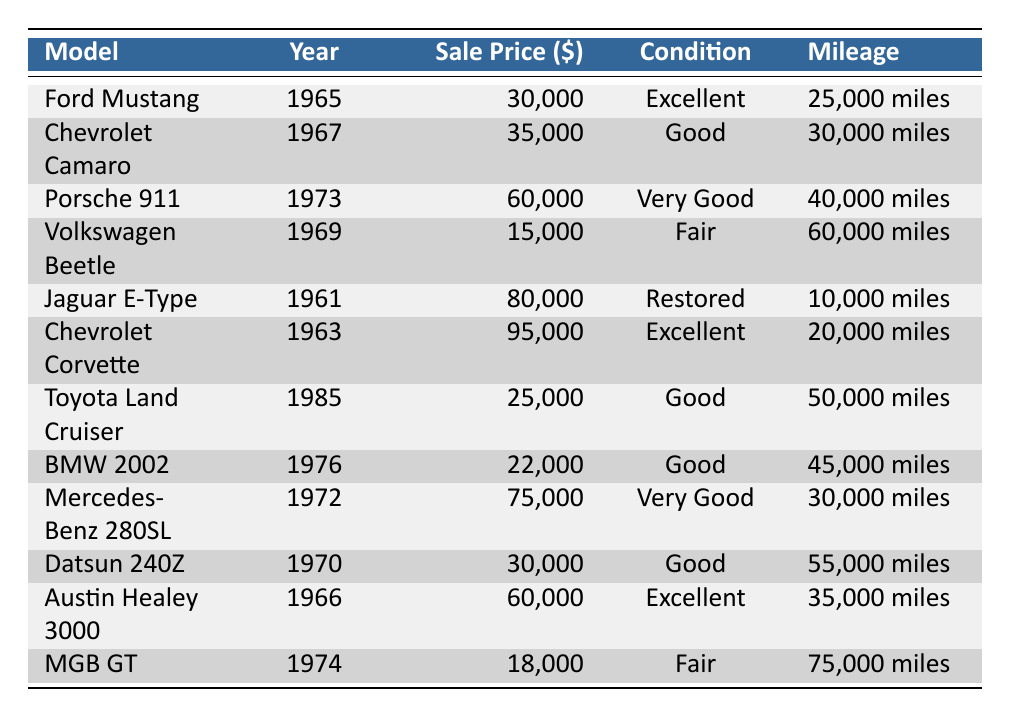What is the sale price of the Chevrolet Corvette? The table shows that the Chevrolet Corvette has a sale price listed as 95,000 dollars in the corresponding row.
Answer: 95,000 Which car has the lowest sale price? By comparing the sale prices listed, the lowest value is 15,000 dollars for the Volkswagen Beetle.
Answer: Volkswagen Beetle How many cars listed are in "Good" condition? The table indicates two cars—Chevrolet Camaro and Toyota Land Cruiser—are classified as "Good" in their respective rows, leading to a total of two.
Answer: 2 What is the average sale price of the cars from the 1960s? The 1960s models are the Ford Mustang, Chevrolet Camaro, Jaguar E-Type, Chevrolet Corvette, Austin Healey 3000, and Volkswagen Beetle. Their prices add up to (30,000 + 35,000 + 80,000 + 95,000 + 60,000 + 15,000) = 315,000 dollars. Since there are 6 models, the average price is 315,000 / 6 = 52,500 dollars.
Answer: 52,500 Is the mileage of the Porsche 911 less than 50,000 miles? The mileage for the Porsche 911 is listed as 40,000 miles, which is indeed less than 50,000.
Answer: Yes Which car from 1970 has a sale price of 30,000 dollars? The table shows that the Datsun 240Z from 1970 has a sale price listed as 30,000 dollars in its respective row.
Answer: Datsun 240Z Which car has the highest sale price among the cars with "Excellent" condition? The Chevrolet Corvette has the highest sale price at 95,000 dollars, while the Ford Mustang and Austin Healey 3000 also have "Excellent" condition (30,000 dollars and 60,000 dollars respectively).
Answer: Chevrolet Corvette What is the price difference between the Jaguar E-Type and the Volkswagen Beetle? The Jaguar E-Type costs 80,000 dollars and the Volkswagen Beetle costs 15,000 dollars. The difference is calculated as 80,000 - 15,000 = 65,000 dollars.
Answer: 65,000 How many cars have a sale price above 60,000 dollars? The cars that meet this criterion are the Porsche 911 (60,000), Jaguar E-Type (80,000), and Chevrolet Corvette (95,000), totaling 3 cars.
Answer: 3 Is there a car from 1985 in the table? Yes, the Toyota Land Cruiser is listed as a 1985 model in the table.
Answer: Yes 